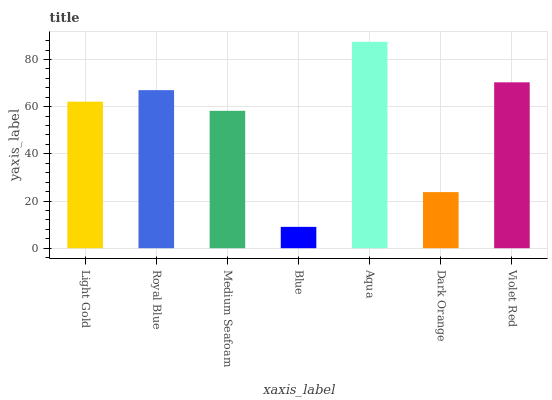Is Blue the minimum?
Answer yes or no. Yes. Is Aqua the maximum?
Answer yes or no. Yes. Is Royal Blue the minimum?
Answer yes or no. No. Is Royal Blue the maximum?
Answer yes or no. No. Is Royal Blue greater than Light Gold?
Answer yes or no. Yes. Is Light Gold less than Royal Blue?
Answer yes or no. Yes. Is Light Gold greater than Royal Blue?
Answer yes or no. No. Is Royal Blue less than Light Gold?
Answer yes or no. No. Is Light Gold the high median?
Answer yes or no. Yes. Is Light Gold the low median?
Answer yes or no. Yes. Is Royal Blue the high median?
Answer yes or no. No. Is Violet Red the low median?
Answer yes or no. No. 